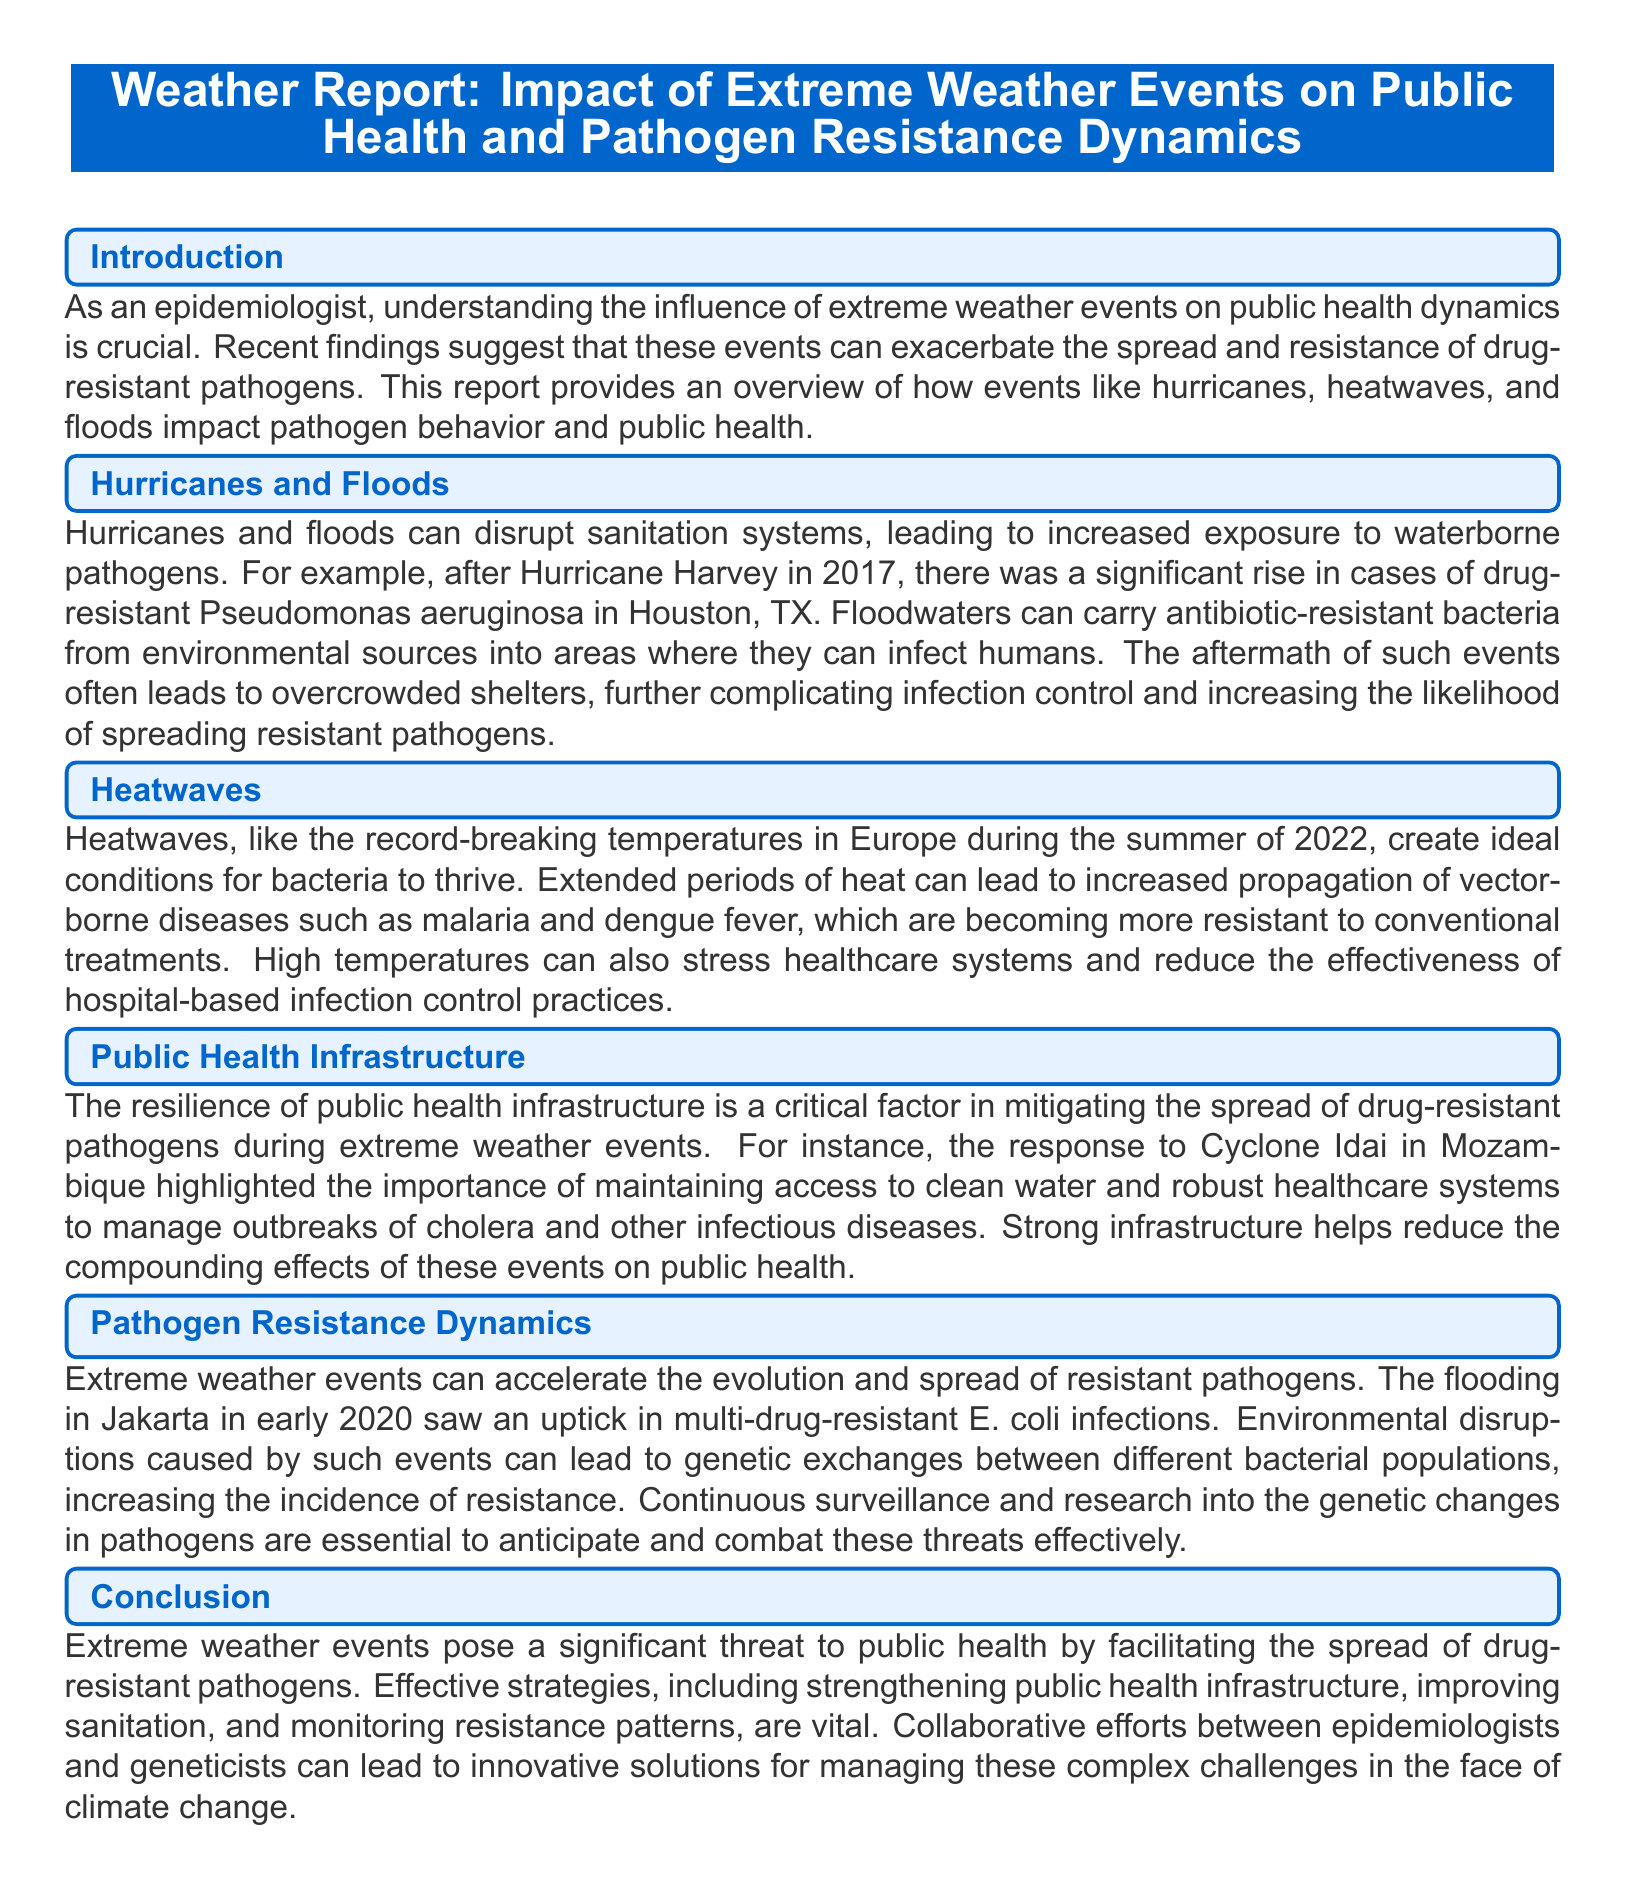What was the significant rise in cases after Hurricane Harvey? The document states that there was a significant rise in cases of drug-resistant Pseudomonas aeruginosa in Houston, TX after Hurricane Harvey in 2017.
Answer: drug-resistant Pseudomonas aeruginosa What extreme weather event is associated with Cyclone Idai? The document mentions that notable responses were taken during Cyclone Idai in Mozambique regarding public health.
Answer: Cyclone Idai What type of diseases are becoming more resistant due to heatwaves? The report discusses that vector-borne diseases such as malaria and dengue fever are becoming more resistant due to conditions created by heatwaves.
Answer: malaria and dengue fever What is highlighted as crucial for managing outbreaks during extreme weather events? The document emphasizes that maintaining access to clean water and robust healthcare systems is critical for managing outbreaks during extreme weather events.
Answer: access to clean water and robust healthcare systems What does the flooding in Jakarta in early 2020 cause an uptick in? According to the report, the flooding in Jakarta led to an uptick in multi-drug-resistant E. coli infections.
Answer: multi-drug-resistant E. coli infections How does extreme weather influence pathogen resistance dynamics? The document explains that extreme weather events can accelerate the evolution and spread of resistant pathogens through environmental disruptions.
Answer: accelerate the evolution and spread What is a proposed solution to combat threats from drug-resistant pathogens? The report suggests that strengthening public health infrastructure is vital to combat threats from drug-resistant pathogens during extreme weather events.
Answer: strengthening public health infrastructure What relationship do extreme weather events and public health have? The document indicates that extreme weather events pose a significant threat to public health by facilitating the spread of drug-resistant pathogens.
Answer: significant threat to public health What is the primary focus of the document type discussed? The report focuses on the impact of extreme weather events on public health and pathogen resistance dynamics.
Answer: impact of extreme weather events on public health and pathogen resistance dynamics 